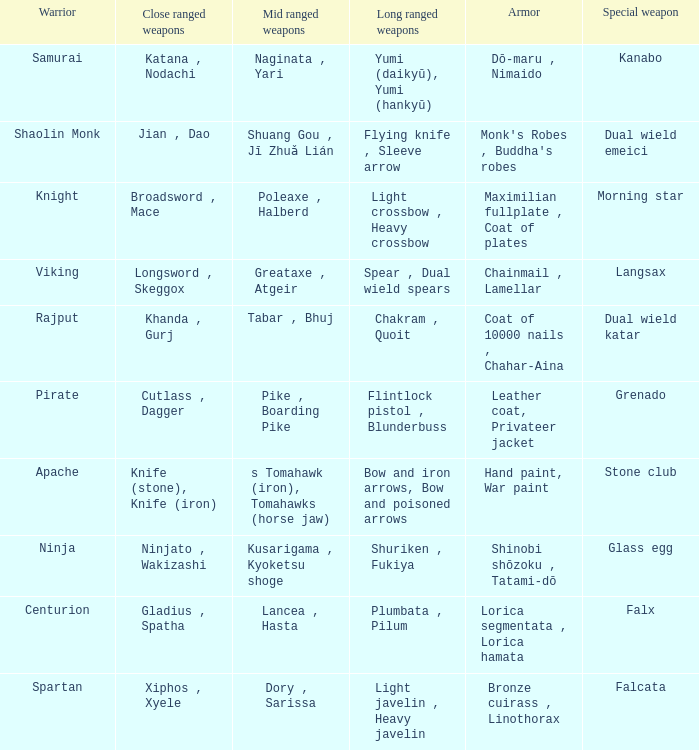If the Close ranged weapons are the knife (stone), knife (iron), what are the Long ranged weapons? Bow and iron arrows, Bow and poisoned arrows. 